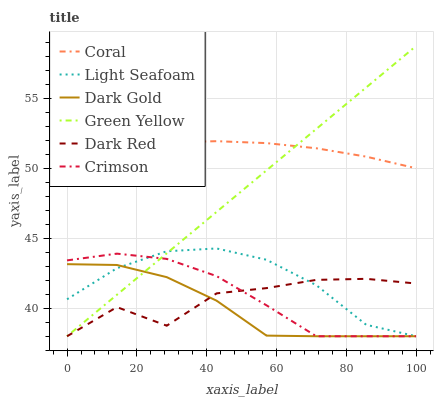Does Dark Gold have the minimum area under the curve?
Answer yes or no. Yes. Does Coral have the maximum area under the curve?
Answer yes or no. Yes. Does Dark Red have the minimum area under the curve?
Answer yes or no. No. Does Dark Red have the maximum area under the curve?
Answer yes or no. No. Is Green Yellow the smoothest?
Answer yes or no. Yes. Is Dark Red the roughest?
Answer yes or no. Yes. Is Dark Gold the smoothest?
Answer yes or no. No. Is Dark Gold the roughest?
Answer yes or no. No. Does Green Yellow have the lowest value?
Answer yes or no. Yes. Does Coral have the lowest value?
Answer yes or no. No. Does Green Yellow have the highest value?
Answer yes or no. Yes. Does Dark Gold have the highest value?
Answer yes or no. No. Is Dark Gold less than Coral?
Answer yes or no. Yes. Is Coral greater than Light Seafoam?
Answer yes or no. Yes. Does Dark Red intersect Dark Gold?
Answer yes or no. Yes. Is Dark Red less than Dark Gold?
Answer yes or no. No. Is Dark Red greater than Dark Gold?
Answer yes or no. No. Does Dark Gold intersect Coral?
Answer yes or no. No. 